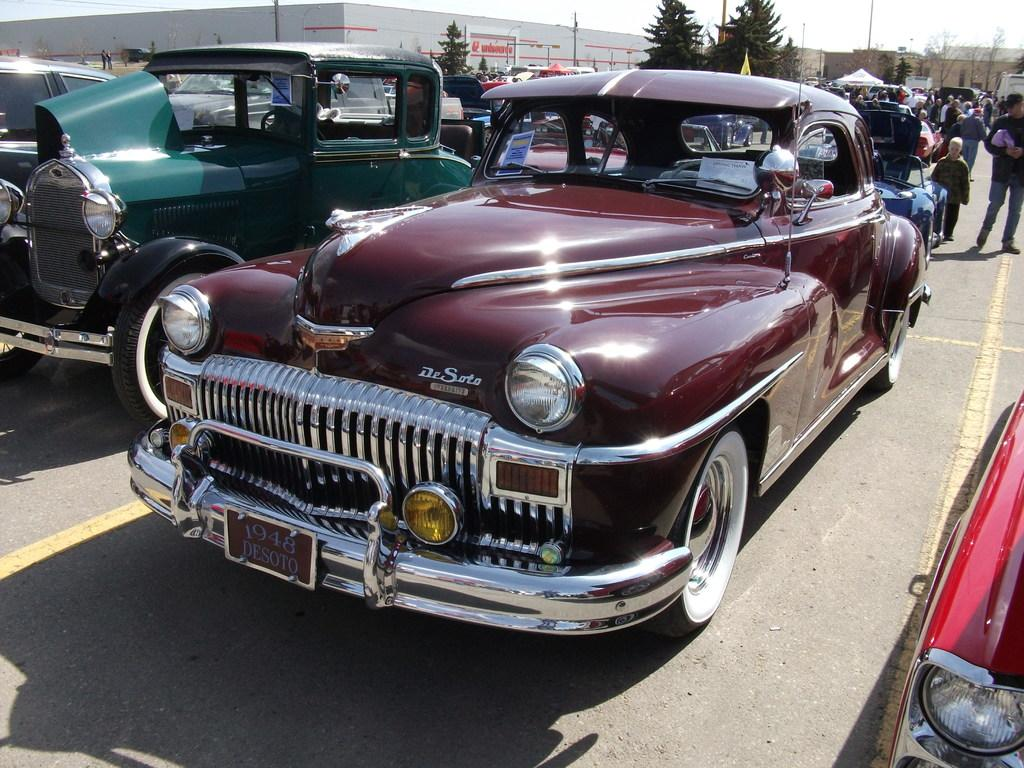What can be seen on the road in the image? There are vehicles on the road in the image. Can you describe the appearance of the vehicles? The vehicles are in different colors. What else is present on the road besides the vehicles? There are people on the road. What type of markings are on the road? The road has yellow color lines. What can be seen in the background of the image? There are trees, buildings, and the sky visible in the background. What type of hat is the tree wearing in the image? There are no hats present in the image, and trees do not wear hats. Can you tell me which verse is being recited by the tail in the image? There are no tails or verses present in the image. 